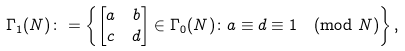<formula> <loc_0><loc_0><loc_500><loc_500>\Gamma _ { 1 } ( N ) & \colon = \left \{ \begin{bmatrix} a & b \\ c & d \end{bmatrix} \in \Gamma _ { 0 } ( N ) \colon a \equiv d \equiv 1 \pmod { N } \right \} ,</formula> 